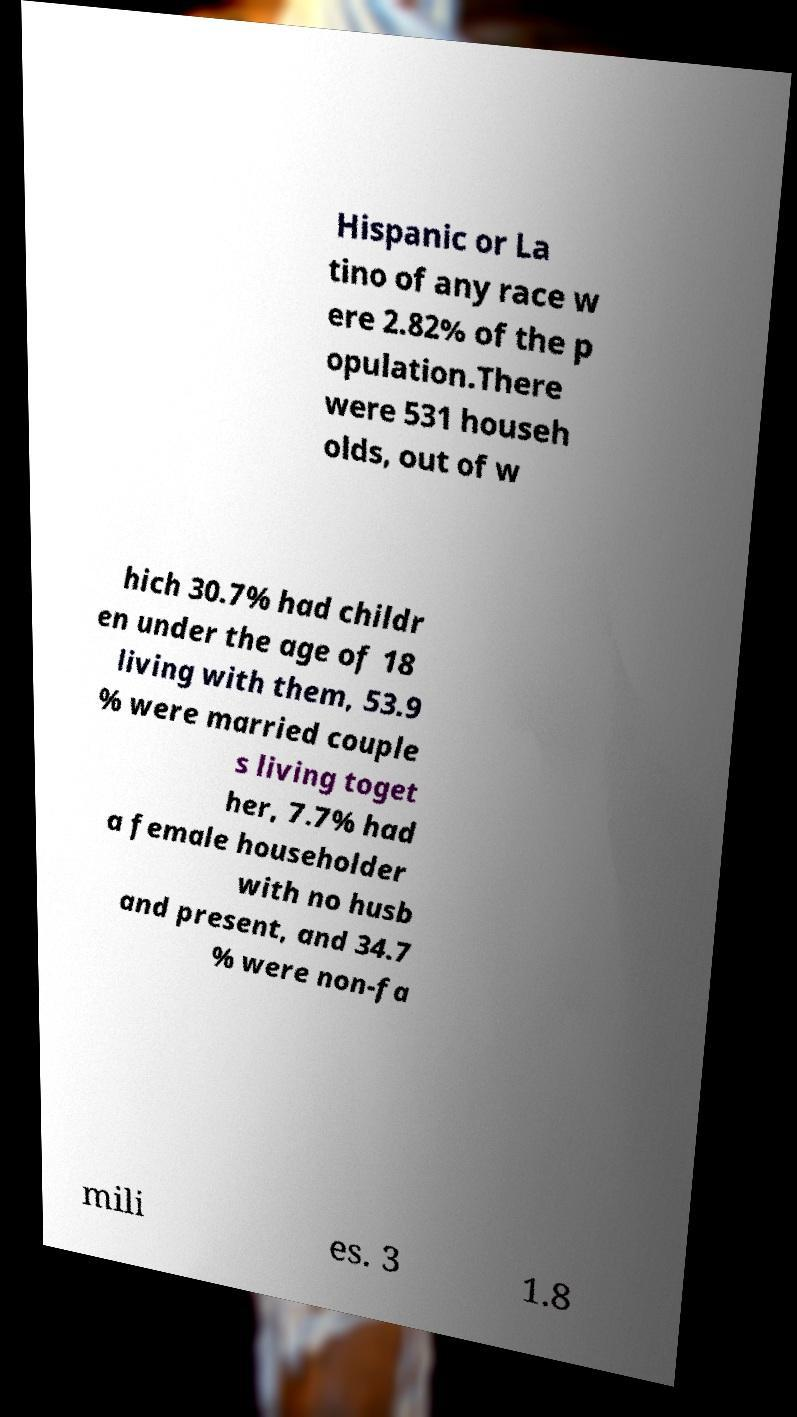What messages or text are displayed in this image? I need them in a readable, typed format. Hispanic or La tino of any race w ere 2.82% of the p opulation.There were 531 househ olds, out of w hich 30.7% had childr en under the age of 18 living with them, 53.9 % were married couple s living toget her, 7.7% had a female householder with no husb and present, and 34.7 % were non-fa mili es. 3 1.8 